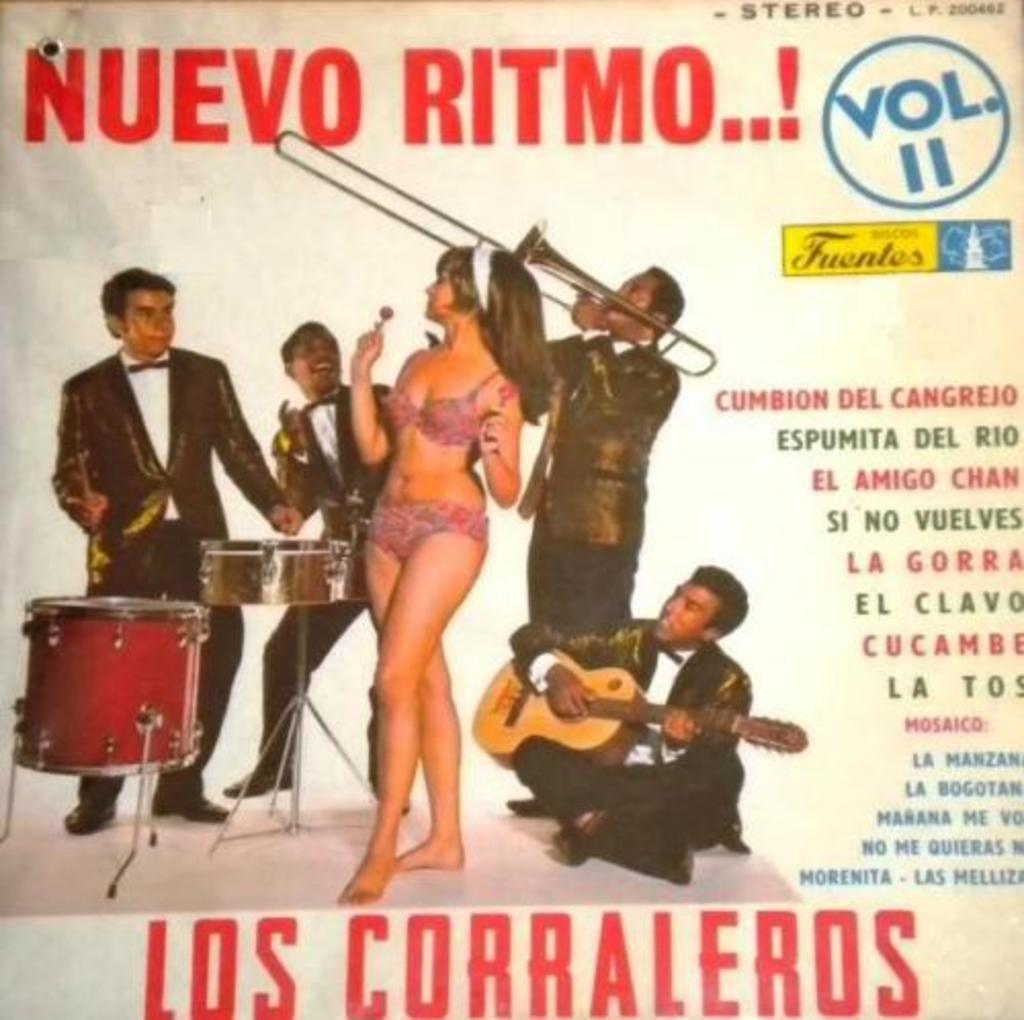What is featured on the poster in the image? The poster depicts people playing musical instruments. Can you describe the main subject in the image? There is a woman standing in the middle of the image. How many waves can be seen crashing on the shore in the image? There are no waves or shore visible in the image; it features a poster and a woman standing in the middle. What type of dolls are present on the sink in the image? There are no dolls or sink present in the image. 